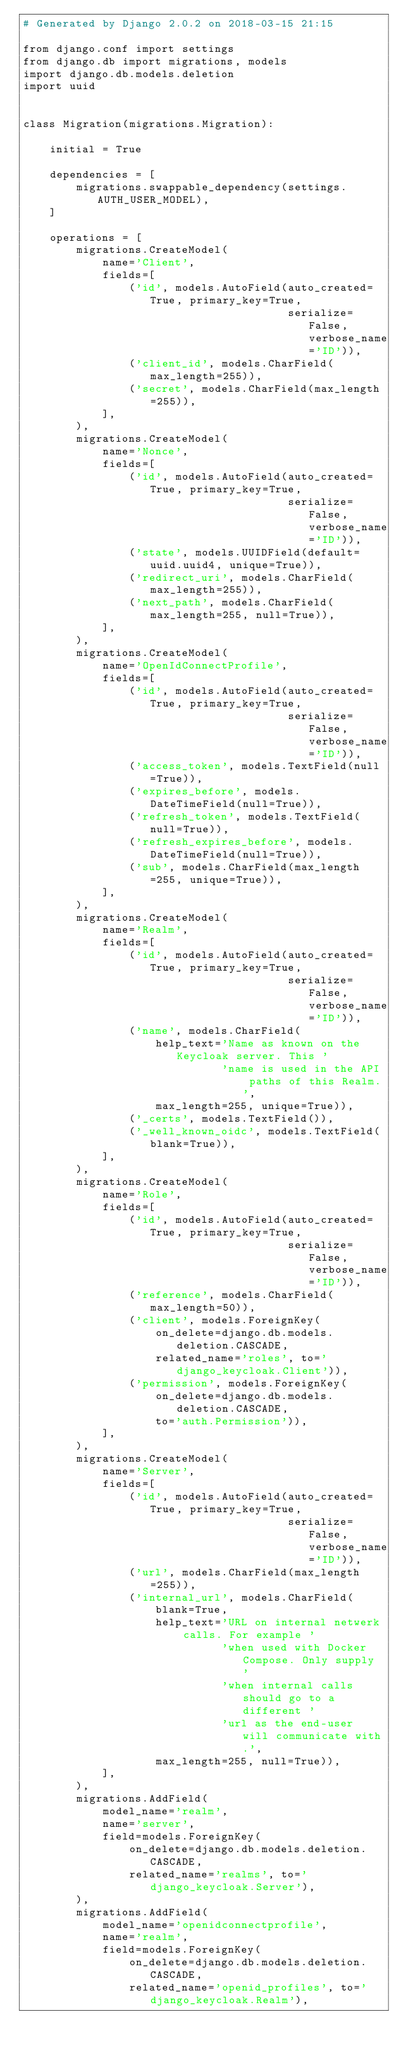Convert code to text. <code><loc_0><loc_0><loc_500><loc_500><_Python_># Generated by Django 2.0.2 on 2018-03-15 21:15

from django.conf import settings
from django.db import migrations, models
import django.db.models.deletion
import uuid


class Migration(migrations.Migration):

    initial = True

    dependencies = [
        migrations.swappable_dependency(settings.AUTH_USER_MODEL),
    ]

    operations = [
        migrations.CreateModel(
            name='Client',
            fields=[
                ('id', models.AutoField(auto_created=True, primary_key=True,
                                        serialize=False, verbose_name='ID')),
                ('client_id', models.CharField(max_length=255)),
                ('secret', models.CharField(max_length=255)),
            ],
        ),
        migrations.CreateModel(
            name='Nonce',
            fields=[
                ('id', models.AutoField(auto_created=True, primary_key=True,
                                        serialize=False, verbose_name='ID')),
                ('state', models.UUIDField(default=uuid.uuid4, unique=True)),
                ('redirect_uri', models.CharField(max_length=255)),
                ('next_path', models.CharField(max_length=255, null=True)),
            ],
        ),
        migrations.CreateModel(
            name='OpenIdConnectProfile',
            fields=[
                ('id', models.AutoField(auto_created=True, primary_key=True,
                                        serialize=False, verbose_name='ID')),
                ('access_token', models.TextField(null=True)),
                ('expires_before', models.DateTimeField(null=True)),
                ('refresh_token', models.TextField(null=True)),
                ('refresh_expires_before', models.DateTimeField(null=True)),
                ('sub', models.CharField(max_length=255, unique=True)),
            ],
        ),
        migrations.CreateModel(
            name='Realm',
            fields=[
                ('id', models.AutoField(auto_created=True, primary_key=True,
                                        serialize=False, verbose_name='ID')),
                ('name', models.CharField(
                    help_text='Name as known on the Keycloak server. This '
                              'name is used in the API paths of this Realm.',
                    max_length=255, unique=True)),
                ('_certs', models.TextField()),
                ('_well_known_oidc', models.TextField(blank=True)),
            ],
        ),
        migrations.CreateModel(
            name='Role',
            fields=[
                ('id', models.AutoField(auto_created=True, primary_key=True,
                                        serialize=False, verbose_name='ID')),
                ('reference', models.CharField(max_length=50)),
                ('client', models.ForeignKey(
                    on_delete=django.db.models.deletion.CASCADE,
                    related_name='roles', to='django_keycloak.Client')),
                ('permission', models.ForeignKey(
                    on_delete=django.db.models.deletion.CASCADE,
                    to='auth.Permission')),
            ],
        ),
        migrations.CreateModel(
            name='Server',
            fields=[
                ('id', models.AutoField(auto_created=True, primary_key=True,
                                        serialize=False, verbose_name='ID')),
                ('url', models.CharField(max_length=255)),
                ('internal_url', models.CharField(
                    blank=True,
                    help_text='URL on internal netwerk calls. For example '
                              'when used with Docker Compose. Only supply '
                              'when internal calls should go to a different '
                              'url as the end-user will communicate with.',
                    max_length=255, null=True)),
            ],
        ),
        migrations.AddField(
            model_name='realm',
            name='server',
            field=models.ForeignKey(
                on_delete=django.db.models.deletion.CASCADE,
                related_name='realms', to='django_keycloak.Server'),
        ),
        migrations.AddField(
            model_name='openidconnectprofile',
            name='realm',
            field=models.ForeignKey(
                on_delete=django.db.models.deletion.CASCADE,
                related_name='openid_profiles', to='django_keycloak.Realm'),</code> 